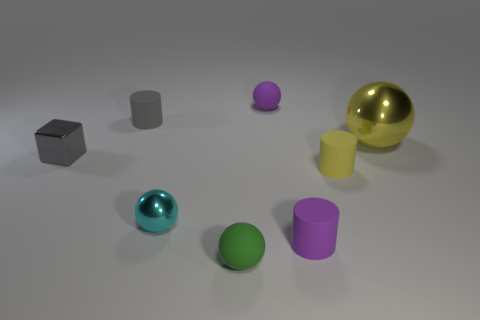The rubber cylinder that is the same color as the big thing is what size?
Offer a very short reply. Small. What number of other blocks are the same color as the cube?
Provide a succinct answer. 0. The green ball that is the same material as the small yellow cylinder is what size?
Provide a short and direct response. Small. There is a metallic object that is to the right of the green matte object; what shape is it?
Make the answer very short. Sphere. There is a gray matte thing that is the same shape as the small yellow thing; what is its size?
Your answer should be compact. Small. What number of cylinders are in front of the tiny matte cylinder that is to the right of the tiny purple object in front of the large yellow ball?
Provide a short and direct response. 1. Is the number of large metallic things in front of the tiny green rubber ball the same as the number of small things?
Keep it short and to the point. No. What number of cubes are large cyan metal objects or green things?
Offer a terse response. 0. Do the large sphere and the metallic block have the same color?
Your response must be concise. No. Is the number of tiny yellow matte cylinders that are left of the small yellow cylinder the same as the number of tiny things that are right of the purple matte sphere?
Make the answer very short. No. 